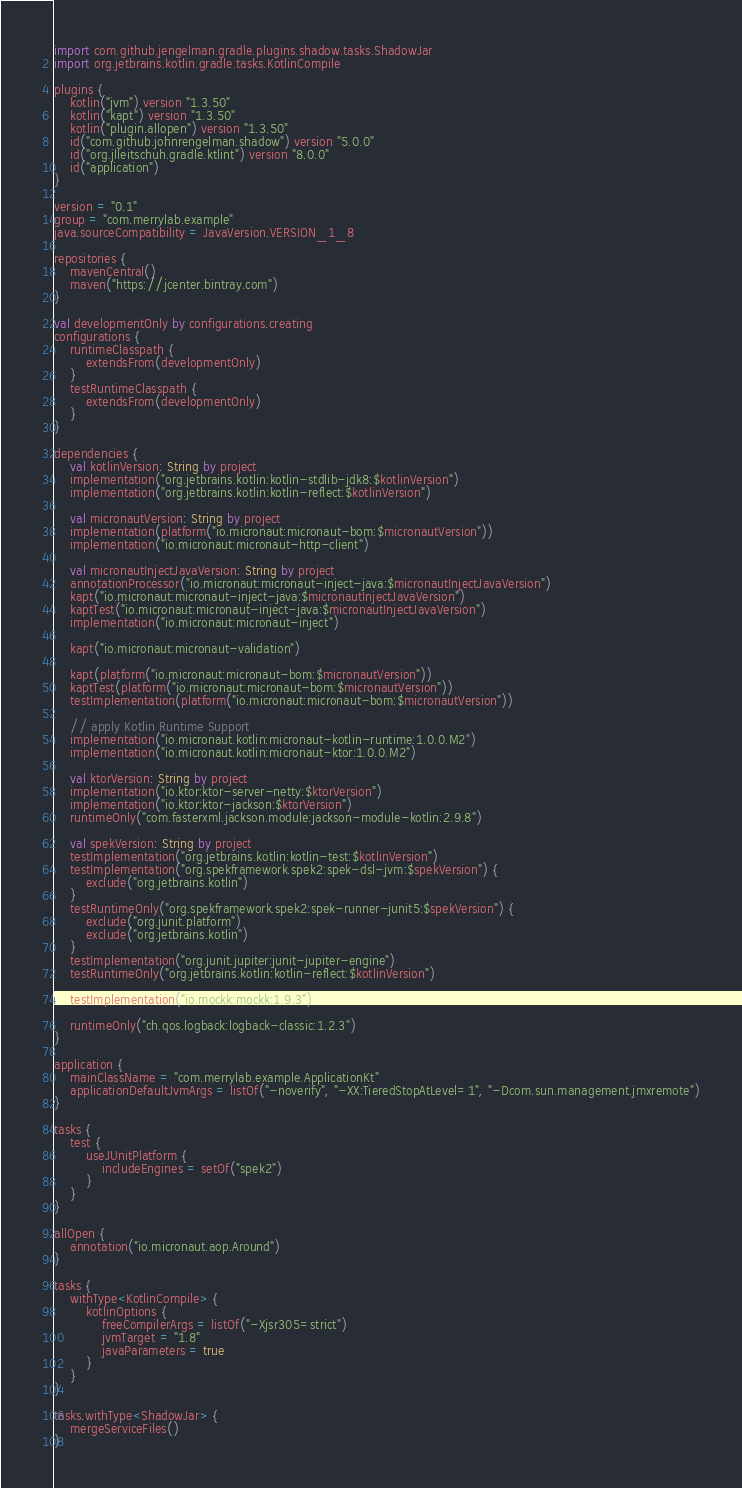Convert code to text. <code><loc_0><loc_0><loc_500><loc_500><_Kotlin_>import com.github.jengelman.gradle.plugins.shadow.tasks.ShadowJar
import org.jetbrains.kotlin.gradle.tasks.KotlinCompile

plugins {
    kotlin("jvm") version "1.3.50"
    kotlin("kapt") version "1.3.50"
    kotlin("plugin.allopen") version "1.3.50"
    id("com.github.johnrengelman.shadow") version "5.0.0"
    id("org.jlleitschuh.gradle.ktlint") version "8.0.0"
    id("application")
}

version = "0.1"
group = "com.merrylab.example"
java.sourceCompatibility = JavaVersion.VERSION_1_8

repositories {
    mavenCentral()
    maven("https://jcenter.bintray.com")
}

val developmentOnly by configurations.creating
configurations {
    runtimeClasspath {
        extendsFrom(developmentOnly)
    }
    testRuntimeClasspath {
        extendsFrom(developmentOnly)
    }
}

dependencies {
    val kotlinVersion: String by project
    implementation("org.jetbrains.kotlin:kotlin-stdlib-jdk8:$kotlinVersion")
    implementation("org.jetbrains.kotlin:kotlin-reflect:$kotlinVersion")

    val micronautVersion: String by project
    implementation(platform("io.micronaut:micronaut-bom:$micronautVersion"))
    implementation("io.micronaut:micronaut-http-client")

    val micronautInjectJavaVersion: String by project
    annotationProcessor("io.micronaut:micronaut-inject-java:$micronautInjectJavaVersion")
    kapt("io.micronaut:micronaut-inject-java:$micronautInjectJavaVersion")
    kaptTest("io.micronaut:micronaut-inject-java:$micronautInjectJavaVersion")
    implementation("io.micronaut:micronaut-inject")

    kapt("io.micronaut:micronaut-validation")

    kapt(platform("io.micronaut:micronaut-bom:$micronautVersion"))
    kaptTest(platform("io.micronaut:micronaut-bom:$micronautVersion"))
    testImplementation(platform("io.micronaut:micronaut-bom:$micronautVersion"))

    // apply Kotlin Runtime Support
    implementation("io.micronaut.kotlin:micronaut-kotlin-runtime:1.0.0.M2")
    implementation("io.micronaut.kotlin:micronaut-ktor:1.0.0.M2")

    val ktorVersion: String by project
    implementation("io.ktor:ktor-server-netty:$ktorVersion")
    implementation("io.ktor:ktor-jackson:$ktorVersion")
    runtimeOnly("com.fasterxml.jackson.module:jackson-module-kotlin:2.9.8")

    val spekVersion: String by project
    testImplementation("org.jetbrains.kotlin:kotlin-test:$kotlinVersion")
    testImplementation("org.spekframework.spek2:spek-dsl-jvm:$spekVersion") {
        exclude("org.jetbrains.kotlin")
    }
    testRuntimeOnly("org.spekframework.spek2:spek-runner-junit5:$spekVersion") {
        exclude("org.junit.platform")
        exclude("org.jetbrains.kotlin")
    }
    testImplementation("org.junit.jupiter:junit-jupiter-engine")
    testRuntimeOnly("org.jetbrains.kotlin:kotlin-reflect:$kotlinVersion")

    testImplementation("io.mockk:mockk:1.9.3")

    runtimeOnly("ch.qos.logback:logback-classic:1.2.3")
}

application {
    mainClassName = "com.merrylab.example.ApplicationKt"
    applicationDefaultJvmArgs = listOf("-noverify", "-XX:TieredStopAtLevel=1", "-Dcom.sun.management.jmxremote")
}

tasks {
    test {
        useJUnitPlatform {
            includeEngines = setOf("spek2")
        }
    }
}

allOpen {
    annotation("io.micronaut.aop.Around")
}

tasks {
    withType<KotlinCompile> {
        kotlinOptions {
            freeCompilerArgs = listOf("-Xjsr305=strict")
            jvmTarget = "1.8"
            javaParameters = true
        }
    }
}

tasks.withType<ShadowJar> {
    mergeServiceFiles()
}
</code> 